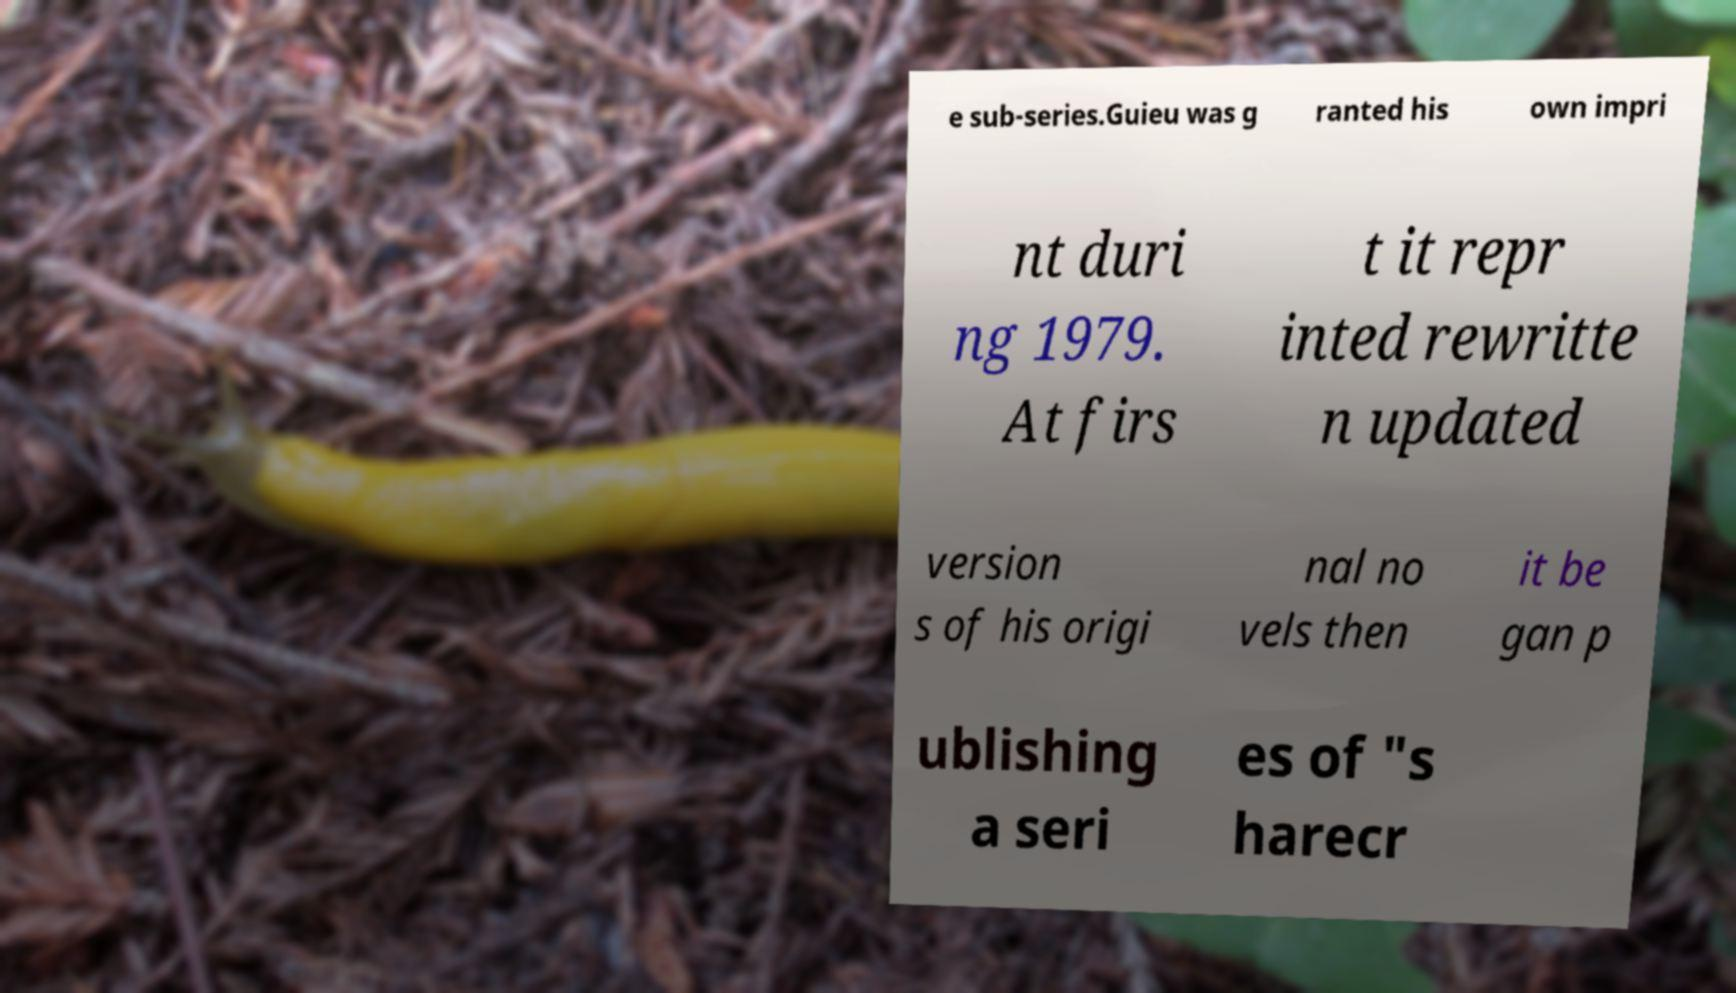I need the written content from this picture converted into text. Can you do that? e sub-series.Guieu was g ranted his own impri nt duri ng 1979. At firs t it repr inted rewritte n updated version s of his origi nal no vels then it be gan p ublishing a seri es of "s harecr 